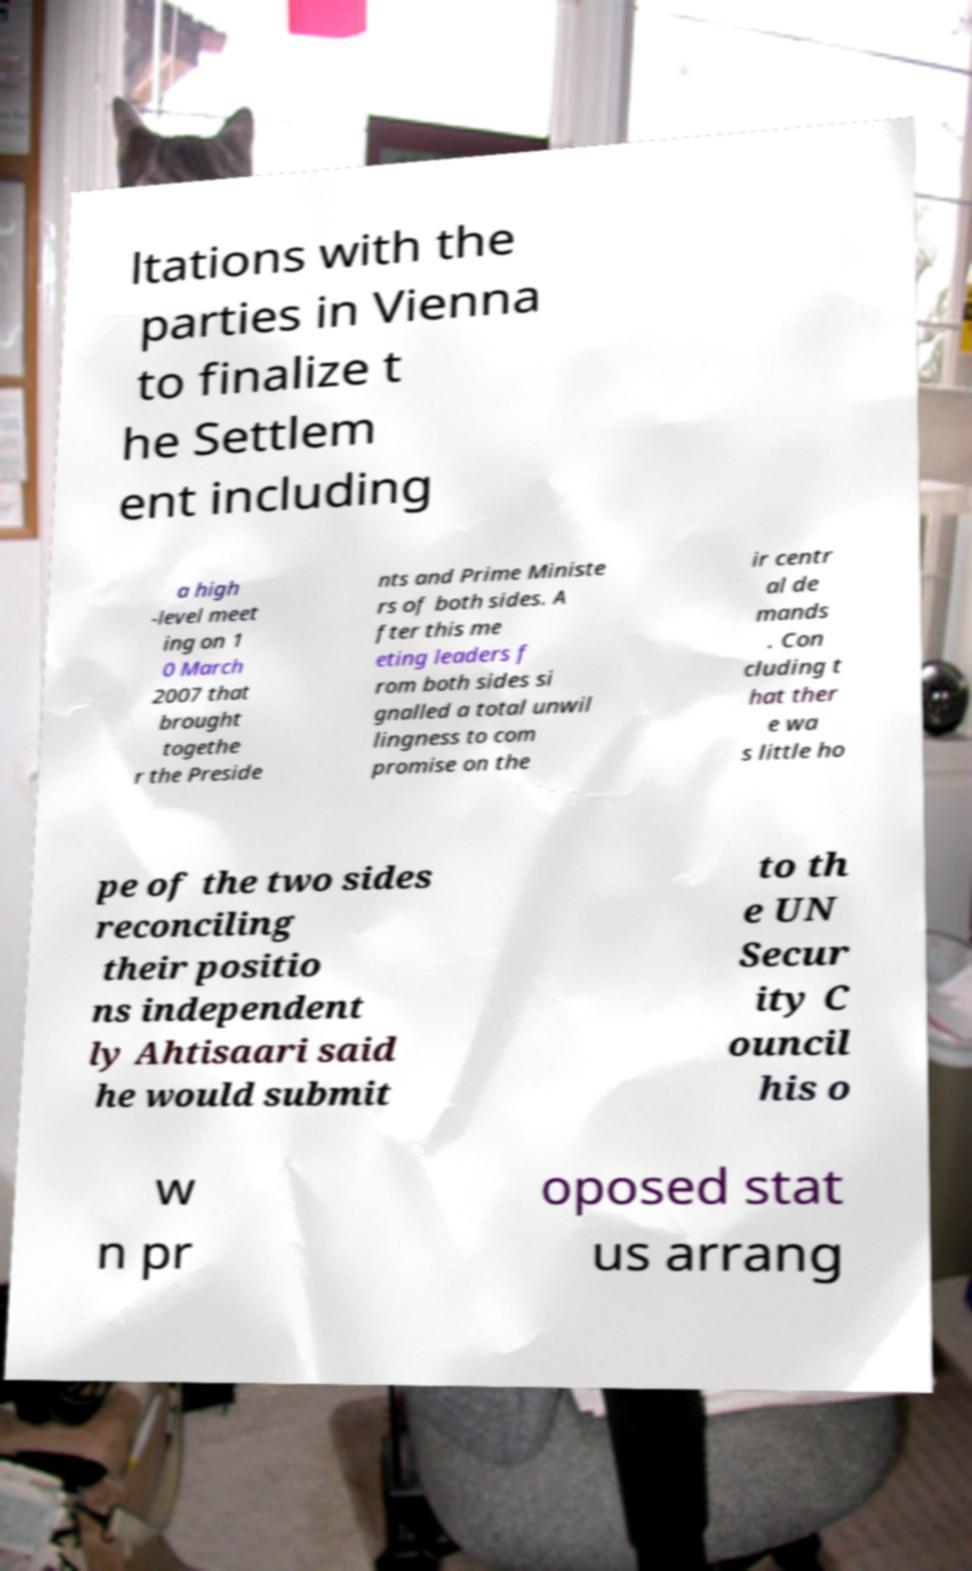Could you assist in decoding the text presented in this image and type it out clearly? ltations with the parties in Vienna to finalize t he Settlem ent including a high -level meet ing on 1 0 March 2007 that brought togethe r the Preside nts and Prime Ministe rs of both sides. A fter this me eting leaders f rom both sides si gnalled a total unwil lingness to com promise on the ir centr al de mands . Con cluding t hat ther e wa s little ho pe of the two sides reconciling their positio ns independent ly Ahtisaari said he would submit to th e UN Secur ity C ouncil his o w n pr oposed stat us arrang 